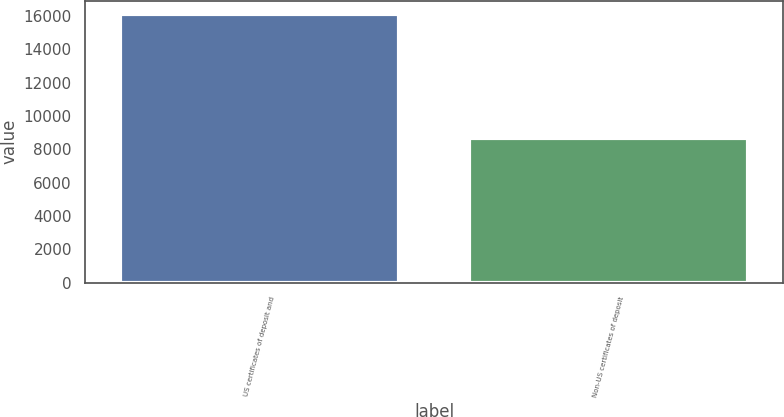<chart> <loc_0><loc_0><loc_500><loc_500><bar_chart><fcel>US certificates of deposit and<fcel>Non-US certificates of deposit<nl><fcel>16112<fcel>8688<nl></chart> 